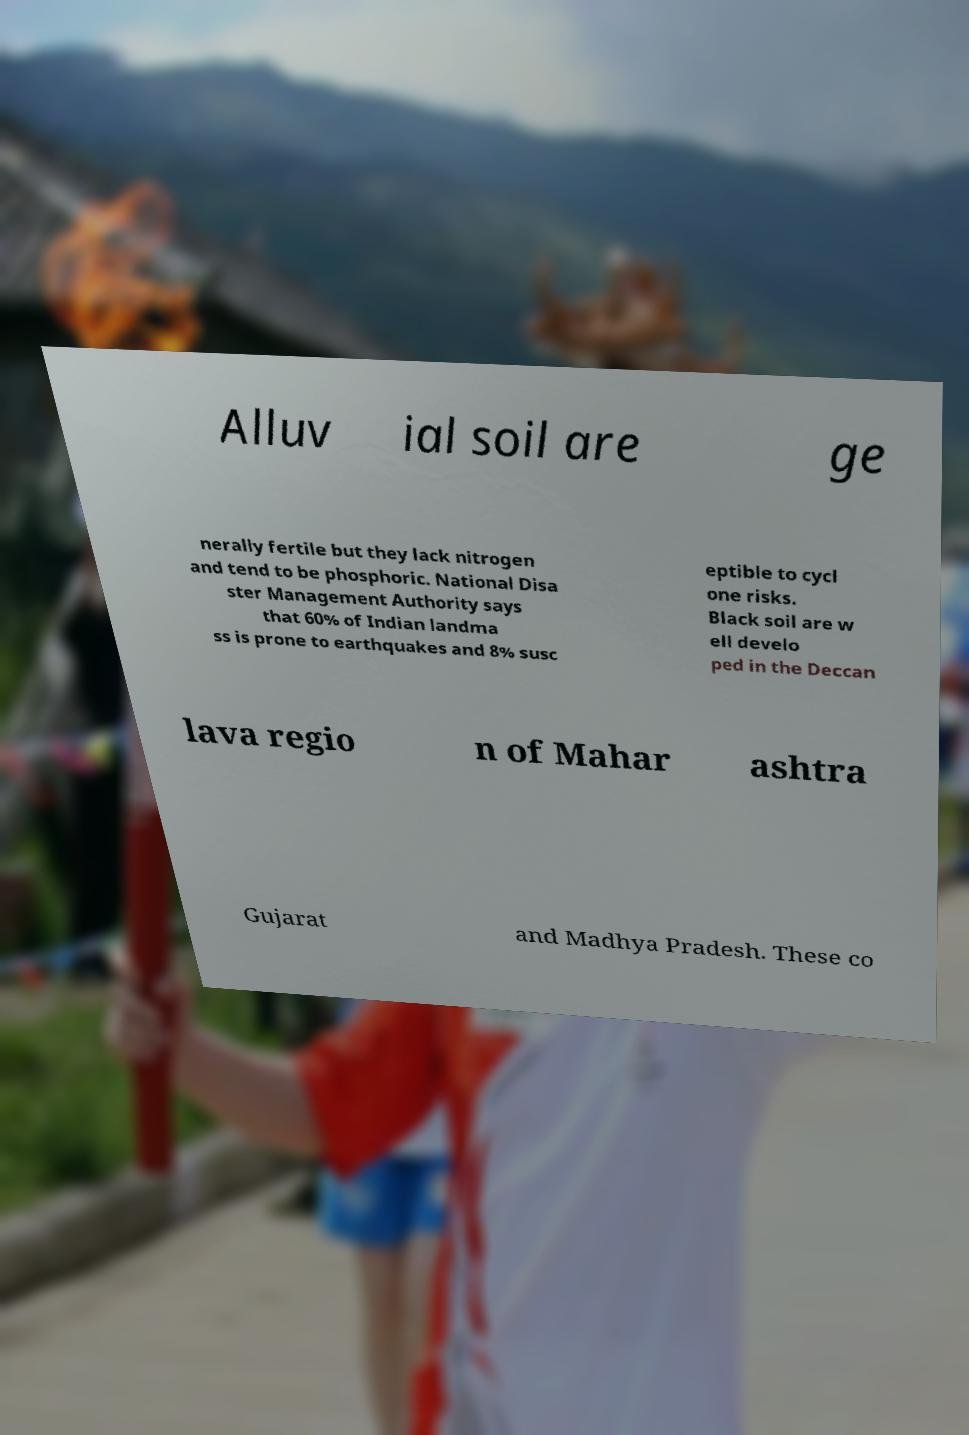There's text embedded in this image that I need extracted. Can you transcribe it verbatim? Alluv ial soil are ge nerally fertile but they lack nitrogen and tend to be phosphoric. National Disa ster Management Authority says that 60% of Indian landma ss is prone to earthquakes and 8% susc eptible to cycl one risks. Black soil are w ell develo ped in the Deccan lava regio n of Mahar ashtra Gujarat and Madhya Pradesh. These co 